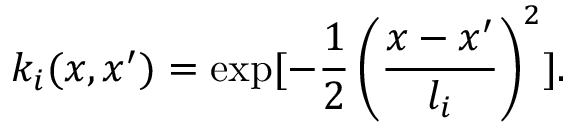Convert formula to latex. <formula><loc_0><loc_0><loc_500><loc_500>k _ { i } ( x , x ^ { \prime } ) = \exp [ - \frac { 1 } { 2 } \left ( \frac { x - x ^ { \prime } } { l _ { i } } \right ) ^ { 2 } ] .</formula> 